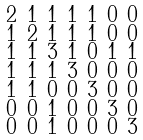<formula> <loc_0><loc_0><loc_500><loc_500>\begin{smallmatrix} 2 & 1 & 1 & 1 & 1 & 0 & 0 \\ 1 & 2 & 1 & 1 & 1 & 0 & 0 \\ 1 & 1 & 3 & 1 & 0 & 1 & 1 \\ 1 & 1 & 1 & 3 & 0 & 0 & 0 \\ 1 & 1 & 0 & 0 & 3 & 0 & 0 \\ 0 & 0 & 1 & 0 & 0 & 3 & 0 \\ 0 & 0 & 1 & 0 & 0 & 0 & 3 \end{smallmatrix}</formula> 